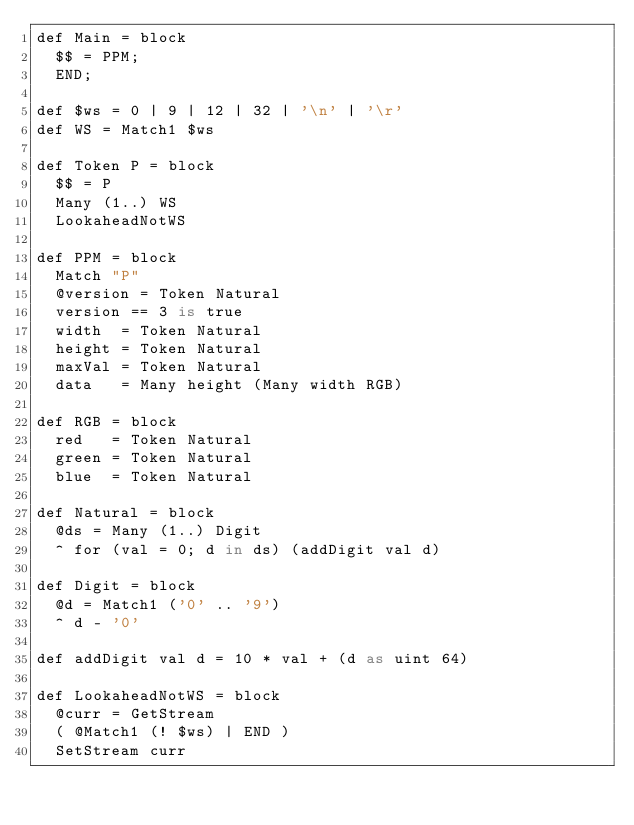<code> <loc_0><loc_0><loc_500><loc_500><_SQL_>def Main = block
  $$ = PPM;
  END;

def $ws = 0 | 9 | 12 | 32 | '\n' | '\r'
def WS = Match1 $ws

def Token P = block
  $$ = P
  Many (1..) WS
  LookaheadNotWS

def PPM = block
  Match "P"
  @version = Token Natural
  version == 3 is true
  width  = Token Natural
  height = Token Natural
  maxVal = Token Natural
  data   = Many height (Many width RGB)

def RGB = block
  red   = Token Natural
  green = Token Natural
  blue  = Token Natural

def Natural = block
  @ds = Many (1..) Digit
  ^ for (val = 0; d in ds) (addDigit val d)

def Digit = block
  @d = Match1 ('0' .. '9')
  ^ d - '0'

def addDigit val d = 10 * val + (d as uint 64)

def LookaheadNotWS = block
  @curr = GetStream
  ( @Match1 (! $ws) | END )
  SetStream curr
</code> 